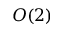Convert formula to latex. <formula><loc_0><loc_0><loc_500><loc_500>O ( 2 )</formula> 